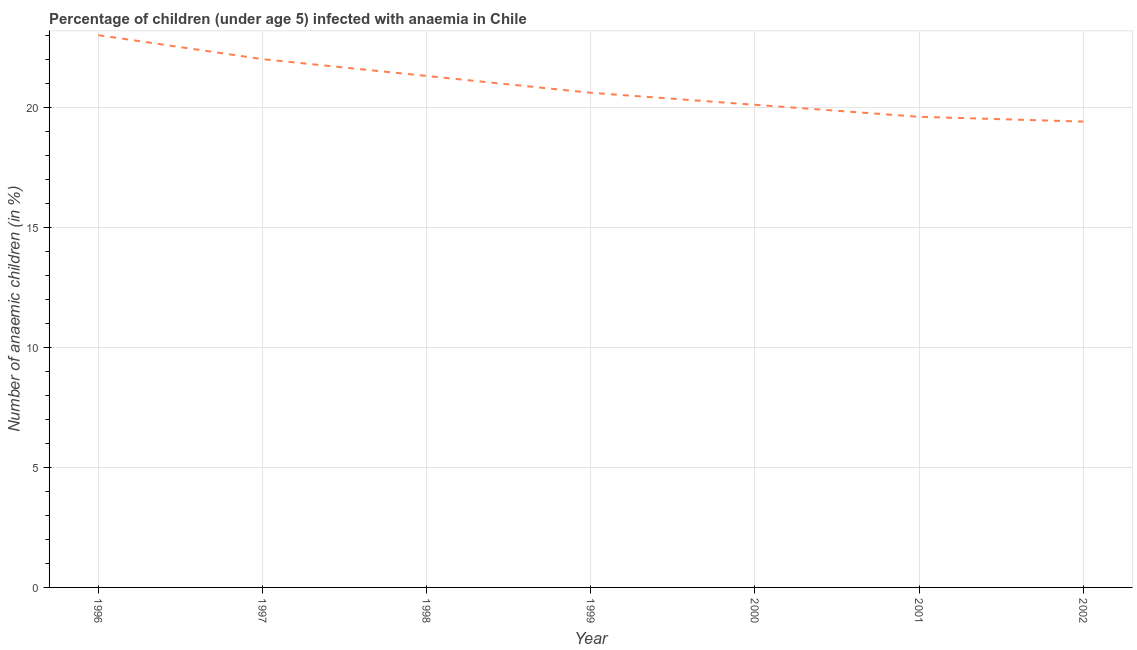What is the number of anaemic children in 1997?
Ensure brevity in your answer.  22. Across all years, what is the minimum number of anaemic children?
Keep it short and to the point. 19.4. In which year was the number of anaemic children minimum?
Your answer should be very brief. 2002. What is the sum of the number of anaemic children?
Keep it short and to the point. 146. What is the difference between the number of anaemic children in 1996 and 1998?
Your answer should be compact. 1.7. What is the average number of anaemic children per year?
Your answer should be compact. 20.86. What is the median number of anaemic children?
Your response must be concise. 20.6. What is the ratio of the number of anaemic children in 1997 to that in 1998?
Offer a very short reply. 1.03. Is the difference between the number of anaemic children in 1997 and 2001 greater than the difference between any two years?
Your answer should be compact. No. Is the sum of the number of anaemic children in 1996 and 2002 greater than the maximum number of anaemic children across all years?
Offer a very short reply. Yes. What is the difference between the highest and the lowest number of anaemic children?
Offer a terse response. 3.6. In how many years, is the number of anaemic children greater than the average number of anaemic children taken over all years?
Your answer should be very brief. 3. Does the number of anaemic children monotonically increase over the years?
Offer a very short reply. No. What is the difference between two consecutive major ticks on the Y-axis?
Your answer should be very brief. 5. Does the graph contain any zero values?
Your response must be concise. No. What is the title of the graph?
Your answer should be very brief. Percentage of children (under age 5) infected with anaemia in Chile. What is the label or title of the Y-axis?
Keep it short and to the point. Number of anaemic children (in %). What is the Number of anaemic children (in %) of 1996?
Give a very brief answer. 23. What is the Number of anaemic children (in %) in 1998?
Provide a succinct answer. 21.3. What is the Number of anaemic children (in %) in 1999?
Keep it short and to the point. 20.6. What is the Number of anaemic children (in %) of 2000?
Ensure brevity in your answer.  20.1. What is the Number of anaemic children (in %) in 2001?
Your response must be concise. 19.6. What is the difference between the Number of anaemic children (in %) in 1996 and 1997?
Your answer should be very brief. 1. What is the difference between the Number of anaemic children (in %) in 1996 and 2000?
Your answer should be very brief. 2.9. What is the difference between the Number of anaemic children (in %) in 1996 and 2001?
Provide a succinct answer. 3.4. What is the difference between the Number of anaemic children (in %) in 1996 and 2002?
Provide a succinct answer. 3.6. What is the difference between the Number of anaemic children (in %) in 1997 and 1998?
Provide a short and direct response. 0.7. What is the difference between the Number of anaemic children (in %) in 1997 and 2000?
Provide a short and direct response. 1.9. What is the difference between the Number of anaemic children (in %) in 1997 and 2002?
Your response must be concise. 2.6. What is the difference between the Number of anaemic children (in %) in 1998 and 2000?
Your response must be concise. 1.2. What is the difference between the Number of anaemic children (in %) in 1998 and 2001?
Provide a short and direct response. 1.7. What is the difference between the Number of anaemic children (in %) in 1999 and 2000?
Offer a very short reply. 0.5. What is the difference between the Number of anaemic children (in %) in 1999 and 2001?
Your response must be concise. 1. What is the difference between the Number of anaemic children (in %) in 1999 and 2002?
Provide a succinct answer. 1.2. What is the ratio of the Number of anaemic children (in %) in 1996 to that in 1997?
Keep it short and to the point. 1.04. What is the ratio of the Number of anaemic children (in %) in 1996 to that in 1999?
Make the answer very short. 1.12. What is the ratio of the Number of anaemic children (in %) in 1996 to that in 2000?
Provide a succinct answer. 1.14. What is the ratio of the Number of anaemic children (in %) in 1996 to that in 2001?
Offer a terse response. 1.17. What is the ratio of the Number of anaemic children (in %) in 1996 to that in 2002?
Make the answer very short. 1.19. What is the ratio of the Number of anaemic children (in %) in 1997 to that in 1998?
Keep it short and to the point. 1.03. What is the ratio of the Number of anaemic children (in %) in 1997 to that in 1999?
Ensure brevity in your answer.  1.07. What is the ratio of the Number of anaemic children (in %) in 1997 to that in 2000?
Your response must be concise. 1.09. What is the ratio of the Number of anaemic children (in %) in 1997 to that in 2001?
Your response must be concise. 1.12. What is the ratio of the Number of anaemic children (in %) in 1997 to that in 2002?
Make the answer very short. 1.13. What is the ratio of the Number of anaemic children (in %) in 1998 to that in 1999?
Give a very brief answer. 1.03. What is the ratio of the Number of anaemic children (in %) in 1998 to that in 2000?
Offer a terse response. 1.06. What is the ratio of the Number of anaemic children (in %) in 1998 to that in 2001?
Ensure brevity in your answer.  1.09. What is the ratio of the Number of anaemic children (in %) in 1998 to that in 2002?
Ensure brevity in your answer.  1.1. What is the ratio of the Number of anaemic children (in %) in 1999 to that in 2000?
Ensure brevity in your answer.  1.02. What is the ratio of the Number of anaemic children (in %) in 1999 to that in 2001?
Offer a very short reply. 1.05. What is the ratio of the Number of anaemic children (in %) in 1999 to that in 2002?
Your answer should be very brief. 1.06. What is the ratio of the Number of anaemic children (in %) in 2000 to that in 2002?
Give a very brief answer. 1.04. What is the ratio of the Number of anaemic children (in %) in 2001 to that in 2002?
Provide a succinct answer. 1.01. 